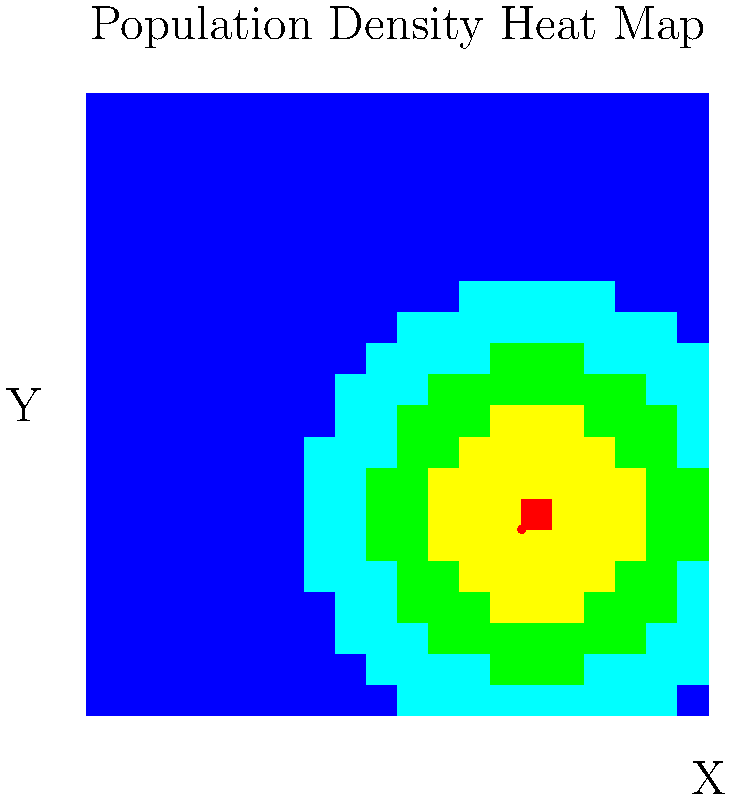Based on the population density heat map provided, where would be the most strategic location to establish a community knowledge hub for maximizing accessibility and impact in rural connectivity efforts? To determine the best location for a community knowledge hub, we need to analyze the population density heat map:

1. Understand the heat map:
   - The colors represent population density, with red indicating high density and blue indicating low density.
   - The X and Y axes represent geographical coordinates.

2. Identify the highest density area:
   - The brightest red spot on the map indicates the highest population density.
   - This point is located at approximately (0.7, 0.3) on the map.

3. Consider accessibility:
   - Placing the hub at the highest density point ensures it's closest to the largest number of people.
   - This location minimizes overall travel distance for the majority of the population.

4. Impact on rural connectivity:
   - The hub at this location can serve as a central point for knowledge sharing and collaboration.
   - It can effectively reach the largest number of people in the surrounding rural areas.

5. Additional considerations:
   - The surrounding areas (orange and yellow) also have relatively high population density.
   - This suggests that the chosen location will also be accessible to nearby communities.

6. Conclusion:
   - The optimal location for the community knowledge hub is at the point of highest population density, (0.7, 0.3).
   - This location balances maximum accessibility with the potential for greatest impact on rural connectivity efforts.
Answer: (0.7, 0.3) 